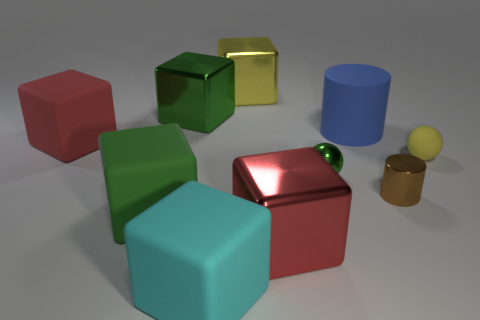Subtract all cyan blocks. How many blocks are left? 5 Subtract all red blocks. How many blocks are left? 4 Subtract 2 cubes. How many cubes are left? 4 Subtract all blue blocks. Subtract all blue cylinders. How many blocks are left? 6 Subtract all cylinders. How many objects are left? 8 Subtract 0 purple cylinders. How many objects are left? 10 Subtract all large metal things. Subtract all small brown shiny cubes. How many objects are left? 7 Add 1 large red things. How many large red things are left? 3 Add 5 big blue metallic objects. How many big blue metallic objects exist? 5 